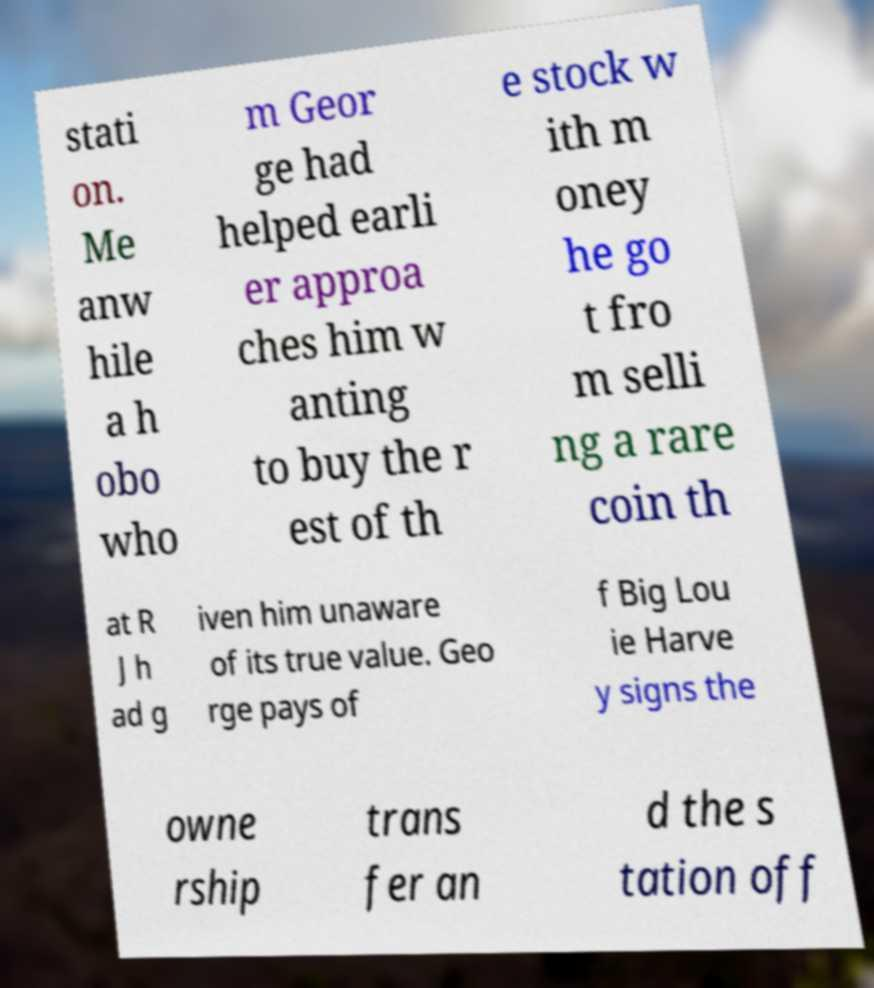Can you read and provide the text displayed in the image?This photo seems to have some interesting text. Can you extract and type it out for me? stati on. Me anw hile a h obo who m Geor ge had helped earli er approa ches him w anting to buy the r est of th e stock w ith m oney he go t fro m selli ng a rare coin th at R J h ad g iven him unaware of its true value. Geo rge pays of f Big Lou ie Harve y signs the owne rship trans fer an d the s tation off 